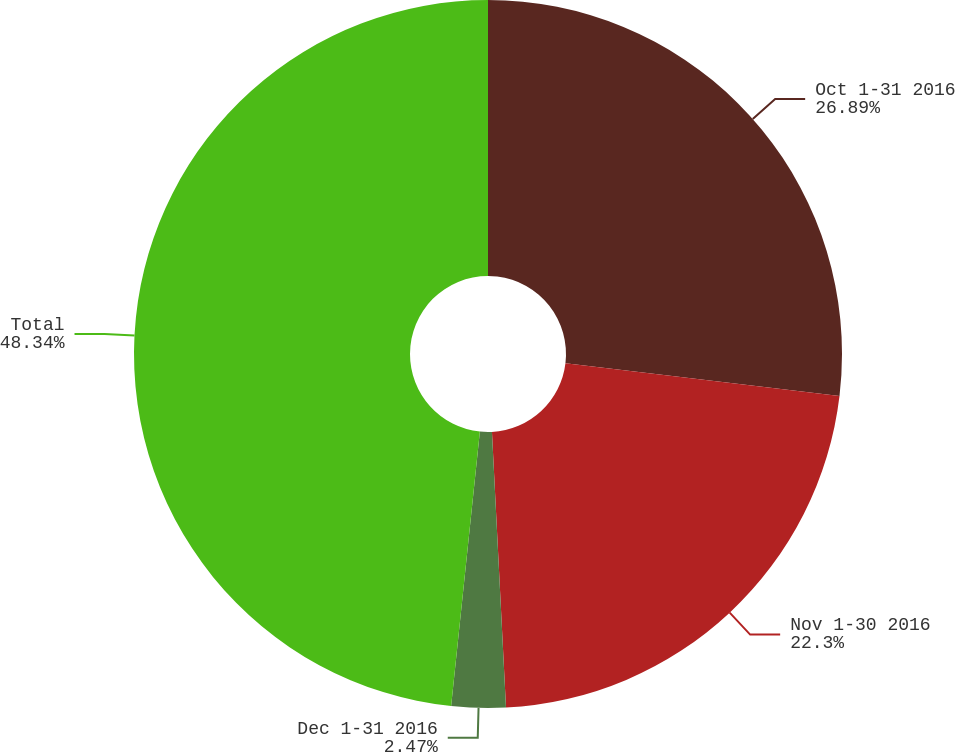<chart> <loc_0><loc_0><loc_500><loc_500><pie_chart><fcel>Oct 1-31 2016<fcel>Nov 1-30 2016<fcel>Dec 1-31 2016<fcel>Total<nl><fcel>26.89%<fcel>22.3%<fcel>2.47%<fcel>48.34%<nl></chart> 